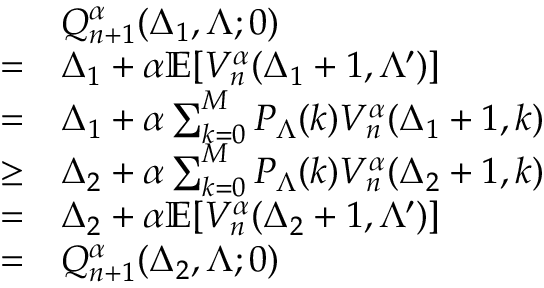Convert formula to latex. <formula><loc_0><loc_0><loc_500><loc_500>\begin{array} { r l } & { Q _ { n + 1 } ^ { \alpha } ( \Delta _ { 1 } , \Lambda ; 0 ) } \\ { = } & { \Delta _ { 1 } + \alpha \mathbb { E } [ V _ { n } ^ { \alpha } ( \Delta _ { 1 } + 1 , \Lambda ^ { \prime } ) ] } \\ { = } & { \Delta _ { 1 } + \alpha \sum _ { k = 0 } ^ { M } P _ { \Lambda } ( k ) V _ { n } ^ { \alpha } ( \Delta _ { 1 } + 1 , k ) } \\ { \geq } & { \Delta _ { 2 } + \alpha \sum _ { k = 0 } ^ { M } P _ { \Lambda } ( k ) V _ { n } ^ { \alpha } ( \Delta _ { 2 } + 1 , k ) } \\ { = } & { \Delta _ { 2 } + \alpha \mathbb { E } [ V _ { n } ^ { \alpha } ( \Delta _ { 2 } + 1 , \Lambda ^ { \prime } ) ] } \\ { = } & { Q _ { n + 1 } ^ { \alpha } ( \Delta _ { 2 } , \Lambda ; 0 ) } \end{array}</formula> 